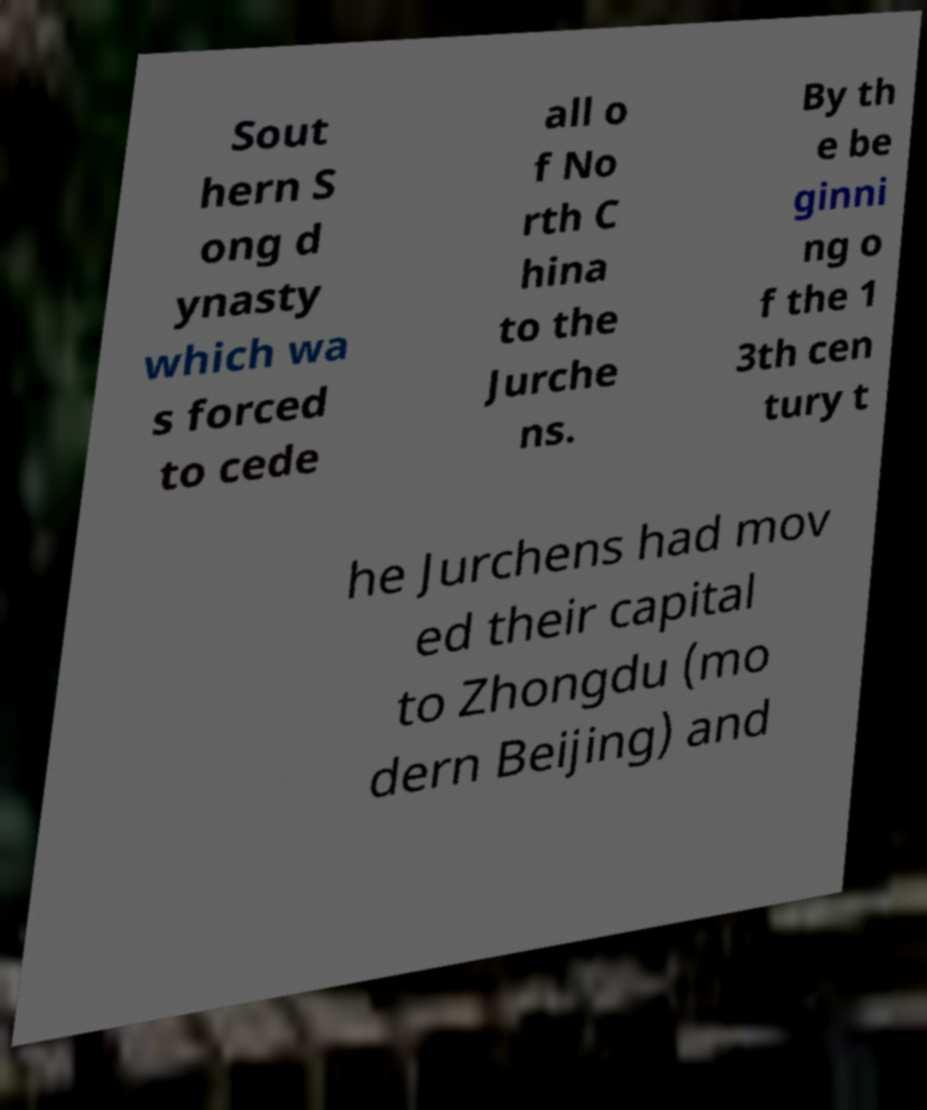Please read and relay the text visible in this image. What does it say? Sout hern S ong d ynasty which wa s forced to cede all o f No rth C hina to the Jurche ns. By th e be ginni ng o f the 1 3th cen tury t he Jurchens had mov ed their capital to Zhongdu (mo dern Beijing) and 